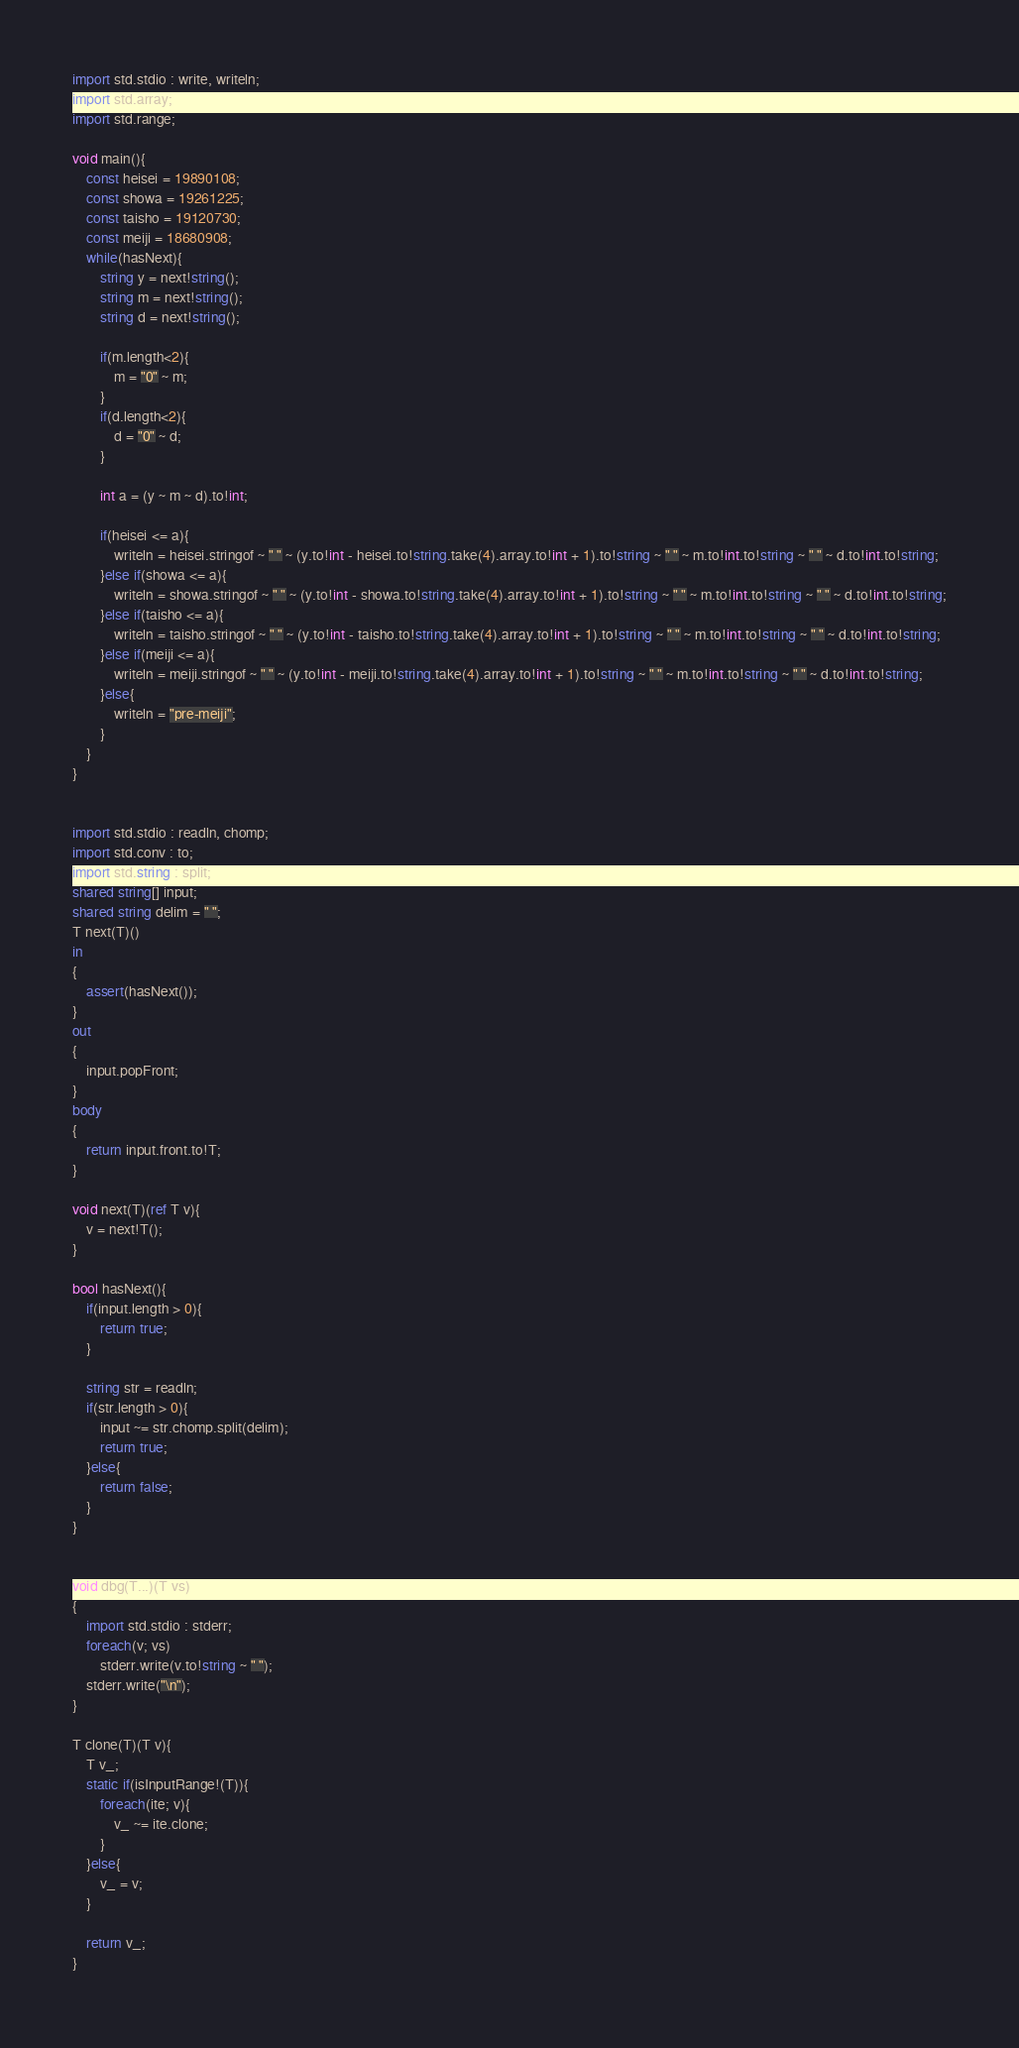Convert code to text. <code><loc_0><loc_0><loc_500><loc_500><_D_>import std.stdio : write, writeln;
import std.array;
import std.range;

void main(){
	const heisei = 19890108;
	const showa = 19261225;
	const taisho = 19120730;
	const meiji = 18680908;
	while(hasNext){
		string y = next!string();
		string m = next!string();
		string d = next!string();
		
		if(m.length<2){
			m = "0" ~ m;
		}
		if(d.length<2){
			d = "0" ~ d;
		}
		
		int a = (y ~ m ~ d).to!int;
		
		if(heisei <= a){
			writeln = heisei.stringof ~ " " ~ (y.to!int - heisei.to!string.take(4).array.to!int + 1).to!string ~ " " ~ m.to!int.to!string ~ " " ~ d.to!int.to!string;
		}else if(showa <= a){
			writeln = showa.stringof ~ " " ~ (y.to!int - showa.to!string.take(4).array.to!int + 1).to!string ~ " " ~ m.to!int.to!string ~ " " ~ d.to!int.to!string;
		}else if(taisho <= a){
			writeln = taisho.stringof ~ " " ~ (y.to!int - taisho.to!string.take(4).array.to!int + 1).to!string ~ " " ~ m.to!int.to!string ~ " " ~ d.to!int.to!string;
		}else if(meiji <= a){
			writeln = meiji.stringof ~ " " ~ (y.to!int - meiji.to!string.take(4).array.to!int + 1).to!string ~ " " ~ m.to!int.to!string ~ " " ~ d.to!int.to!string;
		}else{
			writeln = "pre-meiji";
		}
	}
}


import std.stdio : readln, chomp;
import std.conv : to;
import std.string : split;
shared string[] input;
shared string delim = " ";
T next(T)()
in
{
	assert(hasNext());
}
out
{
	input.popFront;
}
body
{
	return input.front.to!T;
}

void next(T)(ref T v){
	v = next!T();
}

bool hasNext(){
	if(input.length > 0){
		return true;
	}
	
	string str = readln;
	if(str.length > 0){
		input ~= str.chomp.split(delim);
		return true;
	}else{
		return false;
	}
}


void dbg(T...)(T vs)
{
	import std.stdio : stderr;
	foreach(v; vs)
		stderr.write(v.to!string ~ " ");
	stderr.write("\n");
}

T clone(T)(T v){
	T v_;
	static if(isInputRange!(T)){
		foreach(ite; v){
			v_ ~= ite.clone;
		}
	}else{
		v_ = v;
	}
	
	return v_;
}</code> 